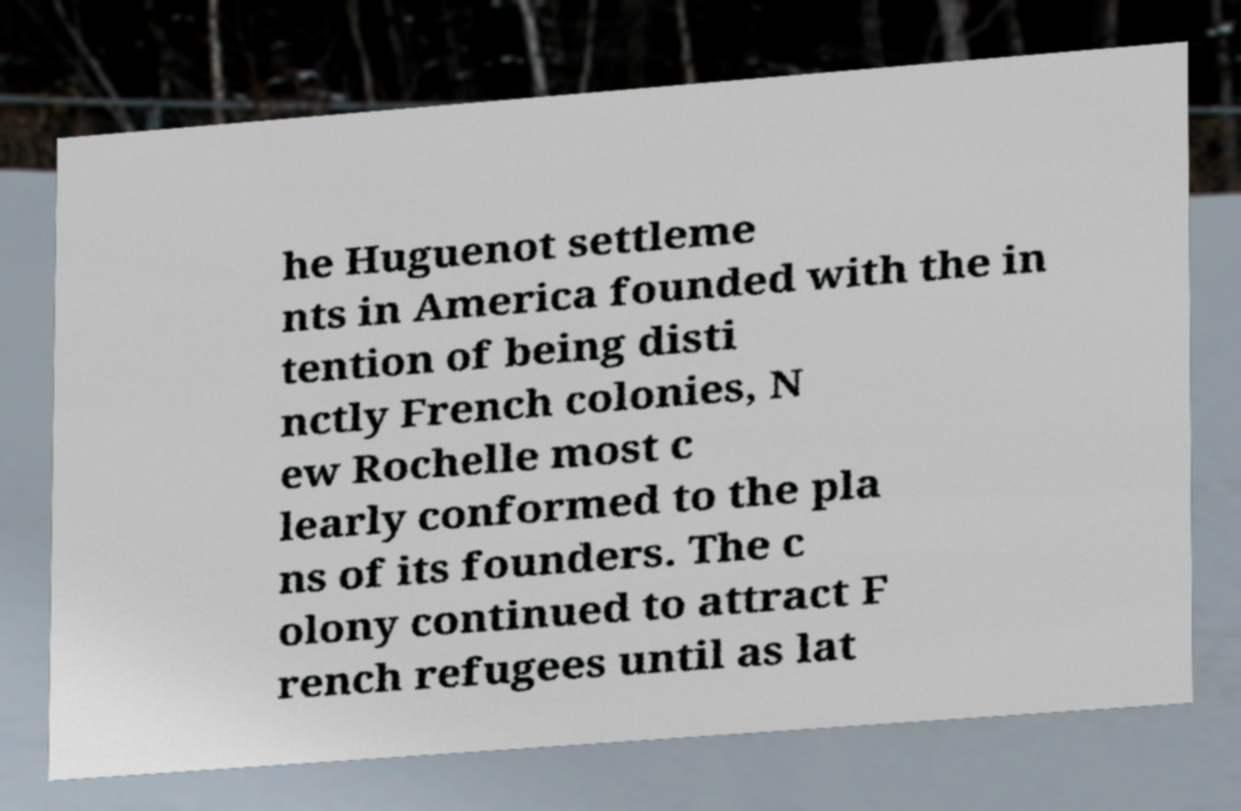For documentation purposes, I need the text within this image transcribed. Could you provide that? he Huguenot settleme nts in America founded with the in tention of being disti nctly French colonies, N ew Rochelle most c learly conformed to the pla ns of its founders. The c olony continued to attract F rench refugees until as lat 